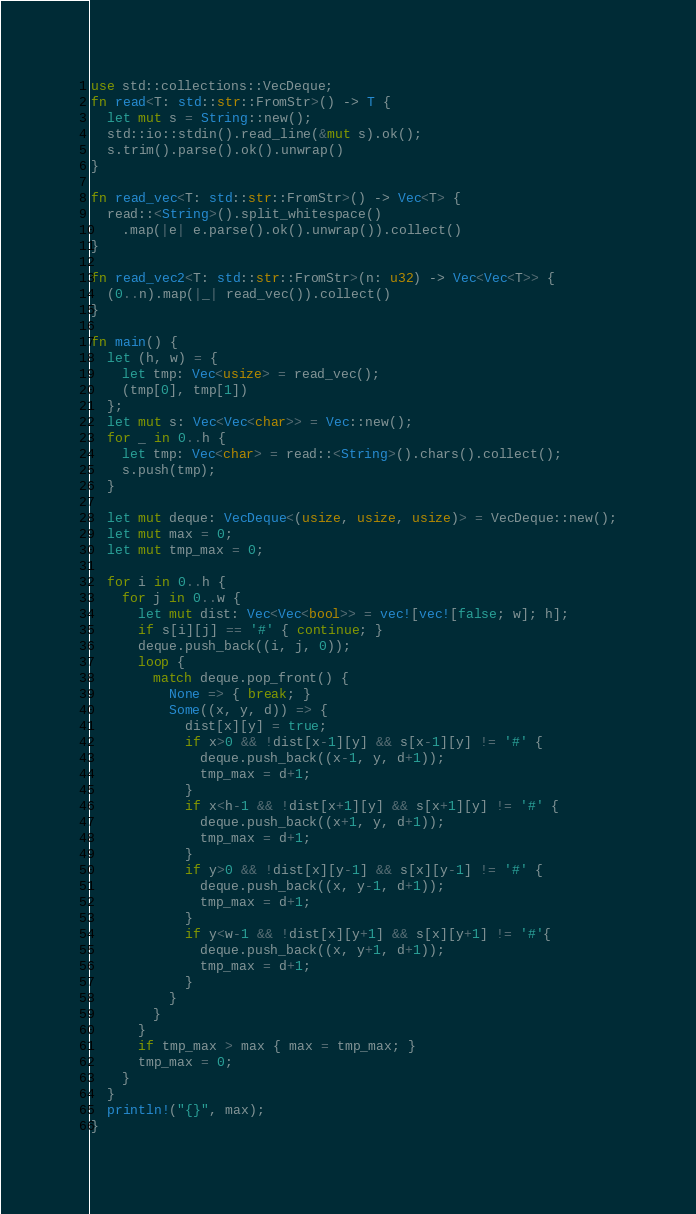<code> <loc_0><loc_0><loc_500><loc_500><_Rust_>use std::collections::VecDeque;
fn read<T: std::str::FromStr>() -> T {
  let mut s = String::new();
  std::io::stdin().read_line(&mut s).ok();
  s.trim().parse().ok().unwrap()
}

fn read_vec<T: std::str::FromStr>() -> Vec<T> {
  read::<String>().split_whitespace()
    .map(|e| e.parse().ok().unwrap()).collect()
}

fn read_vec2<T: std::str::FromStr>(n: u32) -> Vec<Vec<T>> {
  (0..n).map(|_| read_vec()).collect()
}

fn main() {
  let (h, w) = {
    let tmp: Vec<usize> = read_vec();
    (tmp[0], tmp[1])
  };
  let mut s: Vec<Vec<char>> = Vec::new();
  for _ in 0..h {
    let tmp: Vec<char> = read::<String>().chars().collect();
    s.push(tmp);
  }

  let mut deque: VecDeque<(usize, usize, usize)> = VecDeque::new();
  let mut max = 0;
  let mut tmp_max = 0;

  for i in 0..h {
    for j in 0..w {
      let mut dist: Vec<Vec<bool>> = vec![vec![false; w]; h];
      if s[i][j] == '#' { continue; }
      deque.push_back((i, j, 0));
      loop {
        match deque.pop_front() {
          None => { break; }
          Some((x, y, d)) => {
            dist[x][y] = true;
            if x>0 && !dist[x-1][y] && s[x-1][y] != '#' {
              deque.push_back((x-1, y, d+1));
              tmp_max = d+1;
            }
            if x<h-1 && !dist[x+1][y] && s[x+1][y] != '#' {
              deque.push_back((x+1, y, d+1));
              tmp_max = d+1;
            }
            if y>0 && !dist[x][y-1] && s[x][y-1] != '#' {
              deque.push_back((x, y-1, d+1));
              tmp_max = d+1;
            }
            if y<w-1 && !dist[x][y+1] && s[x][y+1] != '#'{
              deque.push_back((x, y+1, d+1));
              tmp_max = d+1;
            }
          }
        }
      }
      if tmp_max > max { max = tmp_max; }
      tmp_max = 0;
    }
  }
  println!("{}", max);
}

</code> 